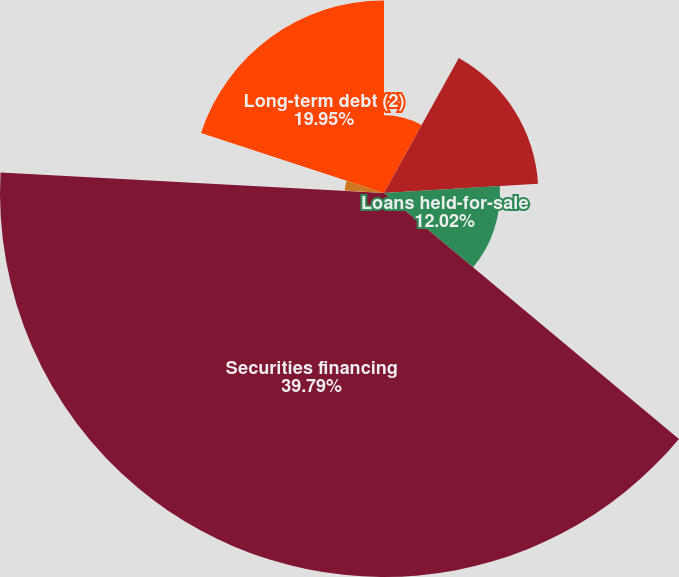Convert chart. <chart><loc_0><loc_0><loc_500><loc_500><pie_chart><fcel>Loans reported as trading<fcel>Consumer and commercial loans<fcel>Loans held-for-sale<fcel>Securities financing<fcel>Other assets<fcel>Long-term deposits<fcel>Long-term debt (2)<nl><fcel>8.05%<fcel>15.99%<fcel>12.02%<fcel>39.79%<fcel>0.12%<fcel>4.08%<fcel>19.95%<nl></chart> 